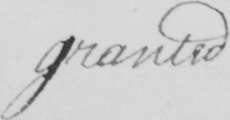Can you read and transcribe this handwriting? granted 